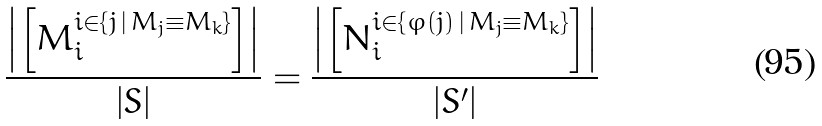<formula> <loc_0><loc_0><loc_500><loc_500>\frac { \left | \left [ M _ { i } ^ { i \in \left \{ j \, | \, M _ { j } \equiv M _ { k } \right \} } \right ] \right | } { \left | S \right | } = \frac { \left | \left [ N _ { i } ^ { i \in \left \{ \varphi \left ( j \right ) \, | \, M _ { j } \equiv M _ { k } \right \} } \right ] \right | } { \left | S ^ { \prime } \right | }</formula> 